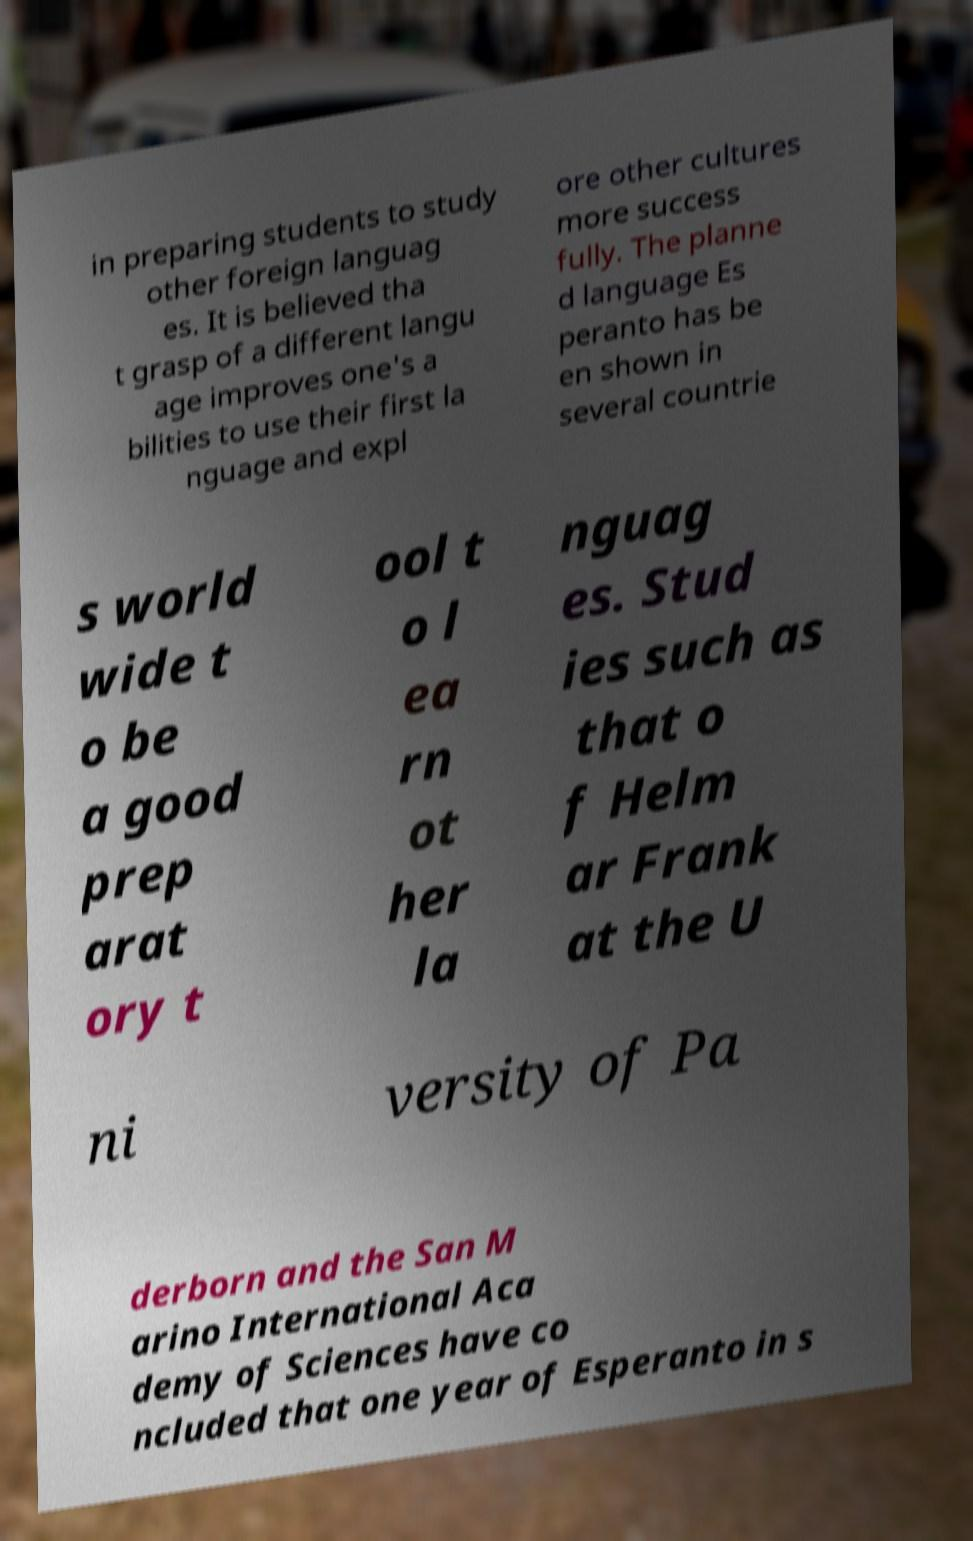For documentation purposes, I need the text within this image transcribed. Could you provide that? in preparing students to study other foreign languag es. It is believed tha t grasp of a different langu age improves one's a bilities to use their first la nguage and expl ore other cultures more success fully. The planne d language Es peranto has be en shown in several countrie s world wide t o be a good prep arat ory t ool t o l ea rn ot her la nguag es. Stud ies such as that o f Helm ar Frank at the U ni versity of Pa derborn and the San M arino International Aca demy of Sciences have co ncluded that one year of Esperanto in s 